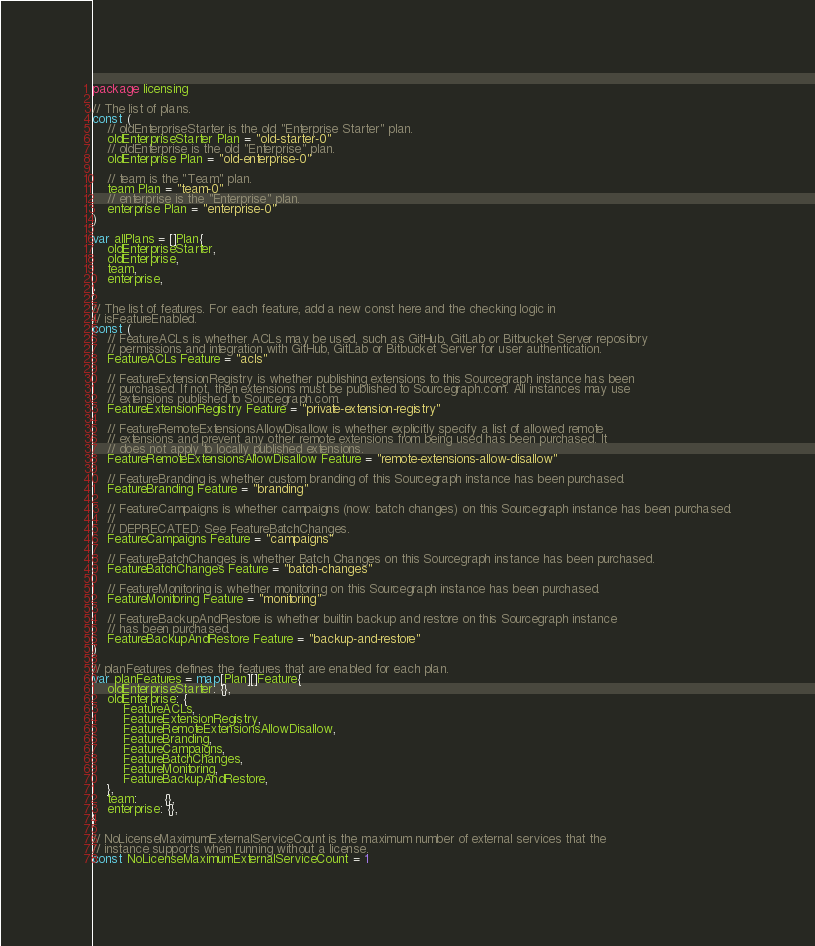<code> <loc_0><loc_0><loc_500><loc_500><_Go_>package licensing

// The list of plans.
const (
	// oldEnterpriseStarter is the old "Enterprise Starter" plan.
	oldEnterpriseStarter Plan = "old-starter-0"
	// oldEnterprise is the old "Enterprise" plan.
	oldEnterprise Plan = "old-enterprise-0"

	// team is the "Team" plan.
	team Plan = "team-0"
	// enterprise is the "Enterprise" plan.
	enterprise Plan = "enterprise-0"
)

var allPlans = []Plan{
	oldEnterpriseStarter,
	oldEnterprise,
	team,
	enterprise,
}

// The list of features. For each feature, add a new const here and the checking logic in
// isFeatureEnabled.
const (
	// FeatureACLs is whether ACLs may be used, such as GitHub, GitLab or Bitbucket Server repository
	// permissions and integration with GitHub, GitLab or Bitbucket Server for user authentication.
	FeatureACLs Feature = "acls"

	// FeatureExtensionRegistry is whether publishing extensions to this Sourcegraph instance has been
	// purchased. If not, then extensions must be published to Sourcegraph.com. All instances may use
	// extensions published to Sourcegraph.com.
	FeatureExtensionRegistry Feature = "private-extension-registry"

	// FeatureRemoteExtensionsAllowDisallow is whether explicitly specify a list of allowed remote
	// extensions and prevent any other remote extensions from being used has been purchased. It
	// does not apply to locally published extensions.
	FeatureRemoteExtensionsAllowDisallow Feature = "remote-extensions-allow-disallow"

	// FeatureBranding is whether custom branding of this Sourcegraph instance has been purchased.
	FeatureBranding Feature = "branding"

	// FeatureCampaigns is whether campaigns (now: batch changes) on this Sourcegraph instance has been purchased.
	//
	// DEPRECATED: See FeatureBatchChanges.
	FeatureCampaigns Feature = "campaigns"

	// FeatureBatchChanges is whether Batch Changes on this Sourcegraph instance has been purchased.
	FeatureBatchChanges Feature = "batch-changes"

	// FeatureMonitoring is whether monitoring on this Sourcegraph instance has been purchased.
	FeatureMonitoring Feature = "monitoring"

	// FeatureBackupAndRestore is whether builtin backup and restore on this Sourcegraph instance
	// has been purchased.
	FeatureBackupAndRestore Feature = "backup-and-restore"
)

// planFeatures defines the features that are enabled for each plan.
var planFeatures = map[Plan][]Feature{
	oldEnterpriseStarter: {},
	oldEnterprise: {
		FeatureACLs,
		FeatureExtensionRegistry,
		FeatureRemoteExtensionsAllowDisallow,
		FeatureBranding,
		FeatureCampaigns,
		FeatureBatchChanges,
		FeatureMonitoring,
		FeatureBackupAndRestore,
	},
	team:       {},
	enterprise: {},
}

// NoLicenseMaximumExternalServiceCount is the maximum number of external services that the
// instance supports when running without a license.
const NoLicenseMaximumExternalServiceCount = 1
</code> 